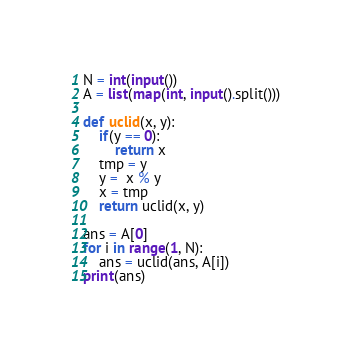<code> <loc_0><loc_0><loc_500><loc_500><_Python_>N = int(input())
A = list(map(int, input().split()))

def uclid(x, y):
    if(y == 0):
        return x
    tmp = y
    y =  x % y
    x = tmp
    return uclid(x, y)

ans = A[0] 
for i in range(1, N):
    ans = uclid(ans, A[i])
print(ans)</code> 